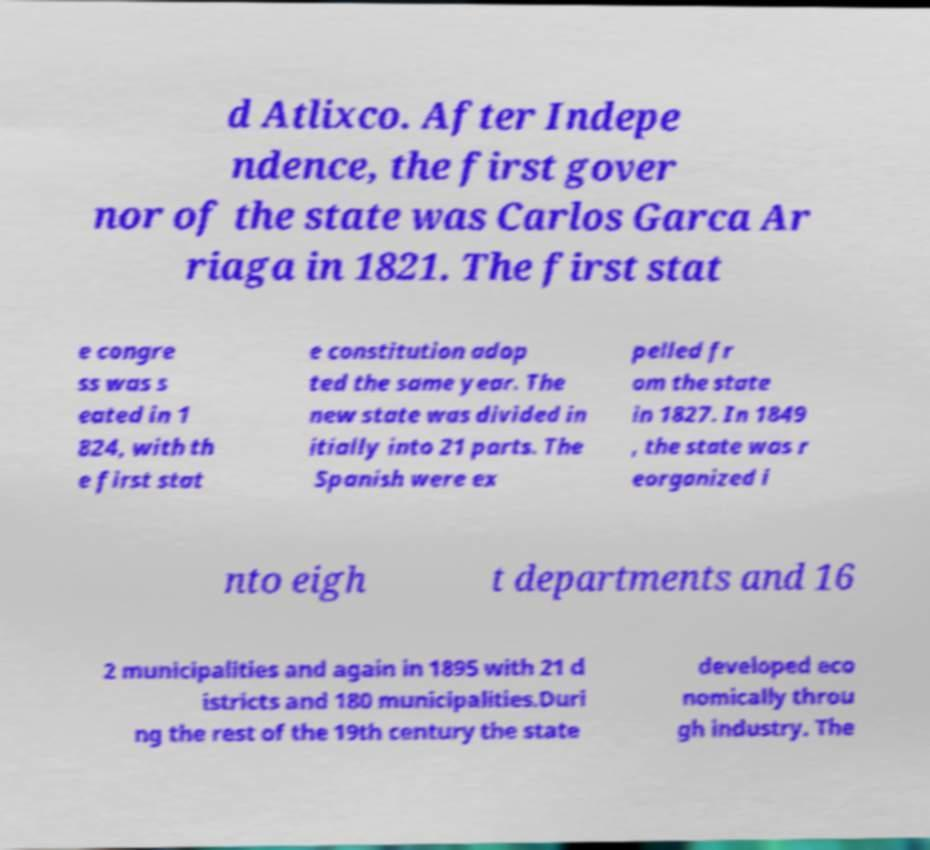What messages or text are displayed in this image? I need them in a readable, typed format. d Atlixco. After Indepe ndence, the first gover nor of the state was Carlos Garca Ar riaga in 1821. The first stat e congre ss was s eated in 1 824, with th e first stat e constitution adop ted the same year. The new state was divided in itially into 21 parts. The Spanish were ex pelled fr om the state in 1827. In 1849 , the state was r eorganized i nto eigh t departments and 16 2 municipalities and again in 1895 with 21 d istricts and 180 municipalities.Duri ng the rest of the 19th century the state developed eco nomically throu gh industry. The 